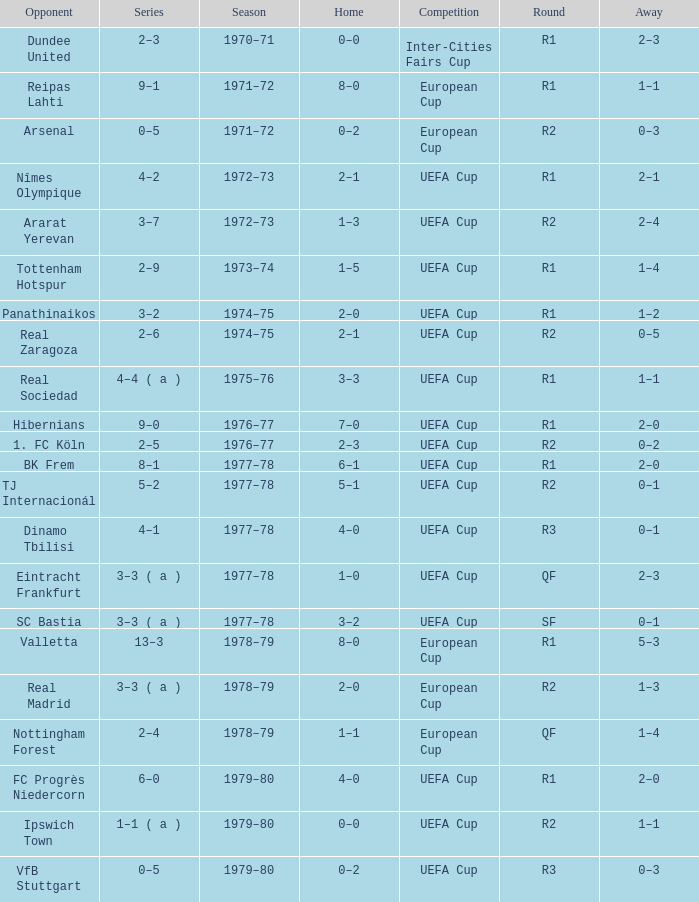Which Round has a Competition of uefa cup, and a Series of 5–2? R2. 